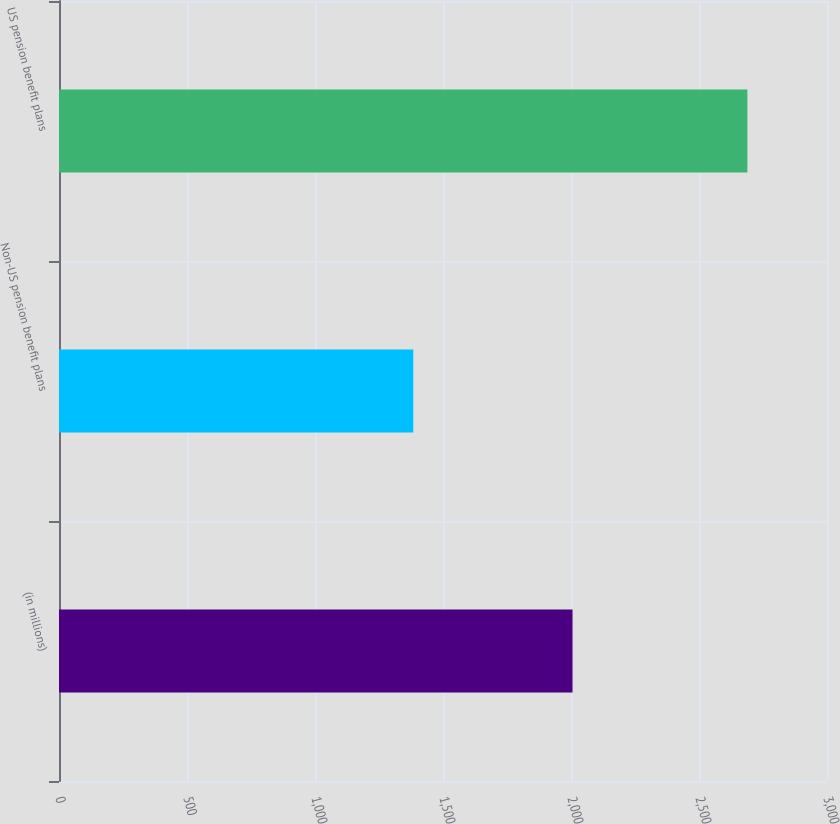<chart> <loc_0><loc_0><loc_500><loc_500><bar_chart><fcel>(in millions)<fcel>Non-US pension benefit plans<fcel>US pension benefit plans<nl><fcel>2006<fcel>1384<fcel>2689<nl></chart> 